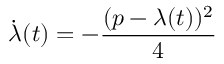<formula> <loc_0><loc_0><loc_500><loc_500>{ \dot { \lambda } } ( t ) = - { \frac { ( p - \lambda ( t ) ) ^ { 2 } } { 4 } }</formula> 